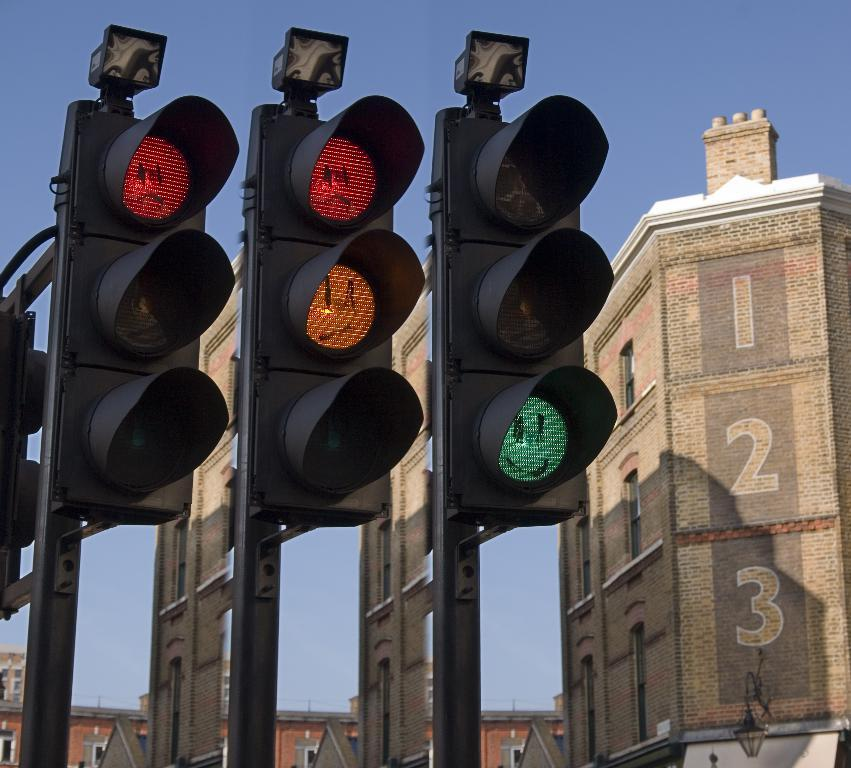<image>
Present a compact description of the photo's key features. Three stop lights with emoji faces on the different lights, next to a building with 1,2,3 numbered down the side. 